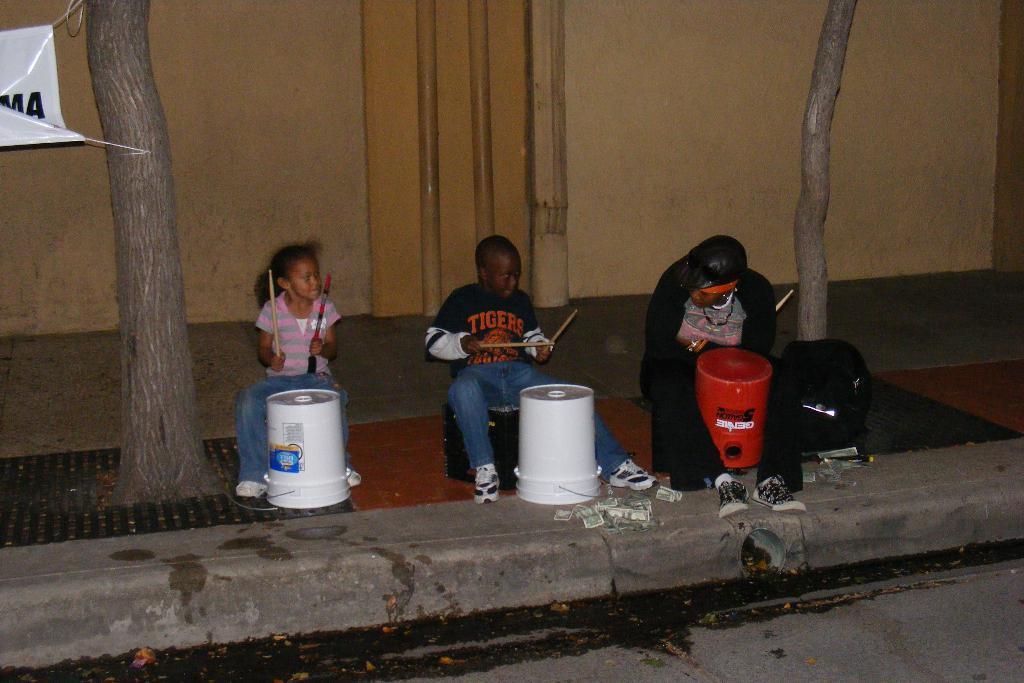Describe this image in one or two sentences. There are three people sitting. These are the buckets, which are in front of the people. They are holding the drumsticks in their hands. I can see the tree trunks. This looks like a building wall. I can see the money lying on the ground. On the left side of the image, this looks like a banner, which is tied to a tree trunk. I think these are the pipes, which are attached to the building wall. 